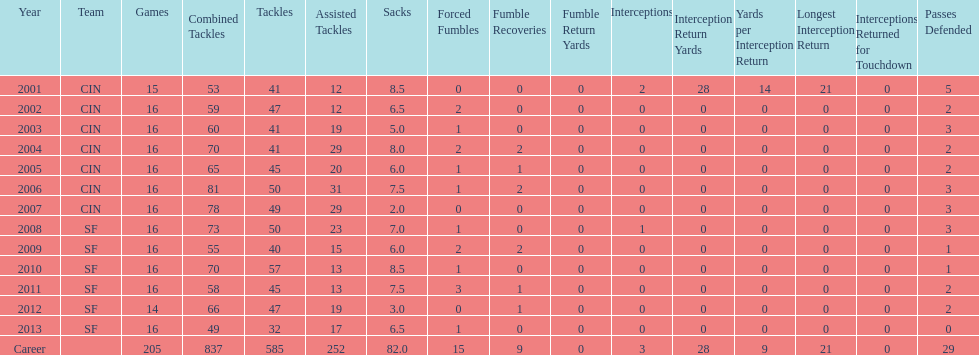What was this player's total number of sacks during their first five seasons? 34. 